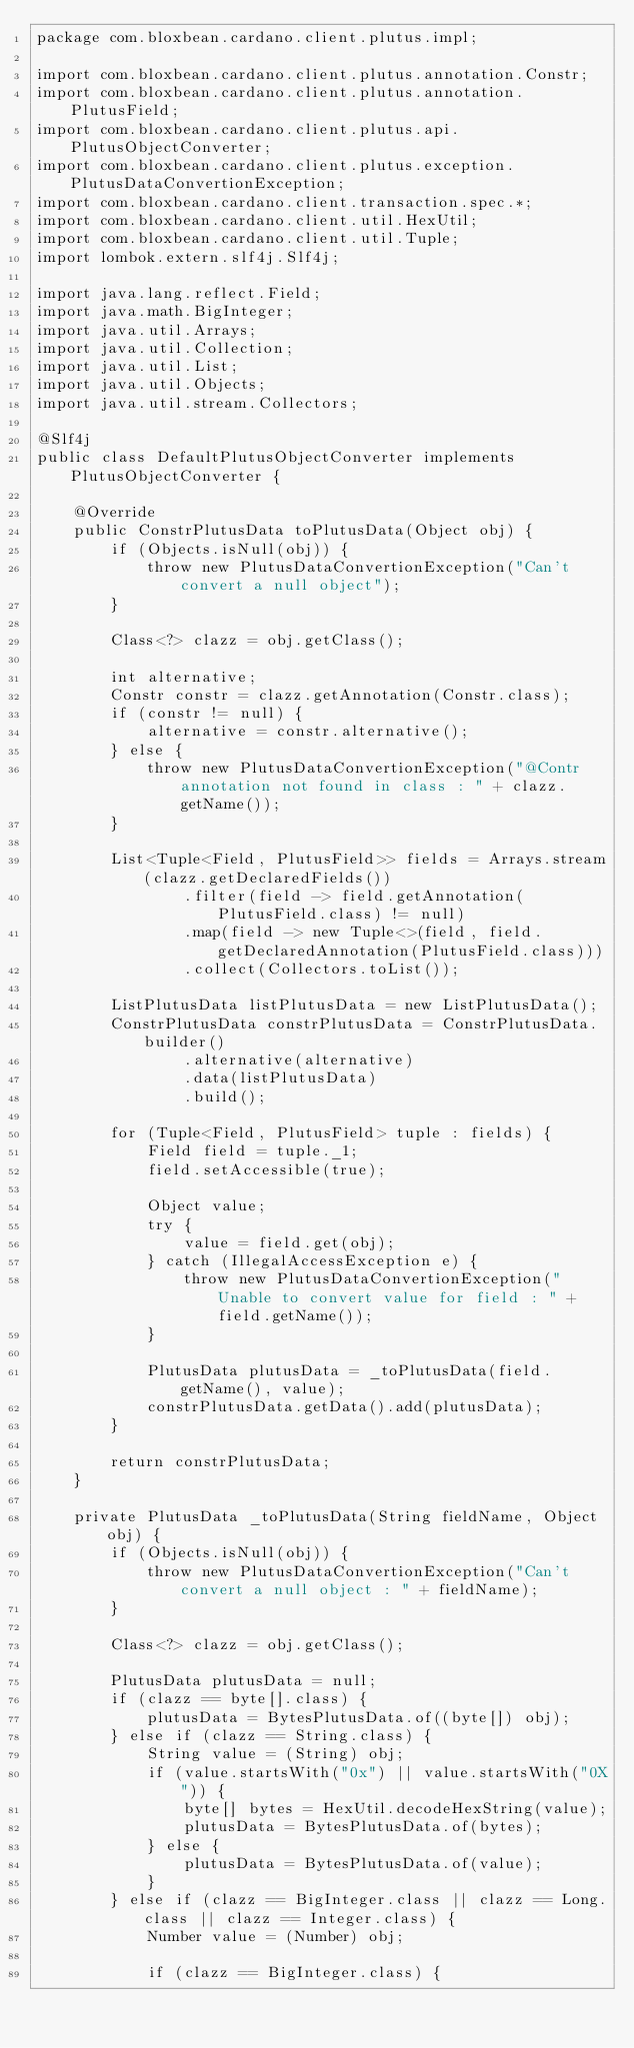<code> <loc_0><loc_0><loc_500><loc_500><_Java_>package com.bloxbean.cardano.client.plutus.impl;

import com.bloxbean.cardano.client.plutus.annotation.Constr;
import com.bloxbean.cardano.client.plutus.annotation.PlutusField;
import com.bloxbean.cardano.client.plutus.api.PlutusObjectConverter;
import com.bloxbean.cardano.client.plutus.exception.PlutusDataConvertionException;
import com.bloxbean.cardano.client.transaction.spec.*;
import com.bloxbean.cardano.client.util.HexUtil;
import com.bloxbean.cardano.client.util.Tuple;
import lombok.extern.slf4j.Slf4j;

import java.lang.reflect.Field;
import java.math.BigInteger;
import java.util.Arrays;
import java.util.Collection;
import java.util.List;
import java.util.Objects;
import java.util.stream.Collectors;

@Slf4j
public class DefaultPlutusObjectConverter implements PlutusObjectConverter {

    @Override
    public ConstrPlutusData toPlutusData(Object obj) {
        if (Objects.isNull(obj)) {
            throw new PlutusDataConvertionException("Can't convert a null object");
        }

        Class<?> clazz = obj.getClass();

        int alternative;
        Constr constr = clazz.getAnnotation(Constr.class);
        if (constr != null) {
            alternative = constr.alternative();
        } else {
            throw new PlutusDataConvertionException("@Contr annotation not found in class : " + clazz.getName());
        }

        List<Tuple<Field, PlutusField>> fields = Arrays.stream(clazz.getDeclaredFields())
                .filter(field -> field.getAnnotation(PlutusField.class) != null)
                .map(field -> new Tuple<>(field, field.getDeclaredAnnotation(PlutusField.class)))
                .collect(Collectors.toList());

        ListPlutusData listPlutusData = new ListPlutusData();
        ConstrPlutusData constrPlutusData = ConstrPlutusData.builder()
                .alternative(alternative)
                .data(listPlutusData)
                .build();

        for (Tuple<Field, PlutusField> tuple : fields) {
            Field field = tuple._1;
            field.setAccessible(true);

            Object value;
            try {
                value = field.get(obj);
            } catch (IllegalAccessException e) {
                throw new PlutusDataConvertionException("Unable to convert value for field : " + field.getName());
            }

            PlutusData plutusData = _toPlutusData(field.getName(), value);
            constrPlutusData.getData().add(plutusData);
        }

        return constrPlutusData;
    }

    private PlutusData _toPlutusData(String fieldName, Object obj) {
        if (Objects.isNull(obj)) {
            throw new PlutusDataConvertionException("Can't convert a null object : " + fieldName);
        }

        Class<?> clazz = obj.getClass();

        PlutusData plutusData = null;
        if (clazz == byte[].class) {
            plutusData = BytesPlutusData.of((byte[]) obj);
        } else if (clazz == String.class) {
            String value = (String) obj;
            if (value.startsWith("0x") || value.startsWith("0X")) {
                byte[] bytes = HexUtil.decodeHexString(value);
                plutusData = BytesPlutusData.of(bytes);
            } else {
                plutusData = BytesPlutusData.of(value);
            }
        } else if (clazz == BigInteger.class || clazz == Long.class || clazz == Integer.class) {
            Number value = (Number) obj;

            if (clazz == BigInteger.class) {</code> 